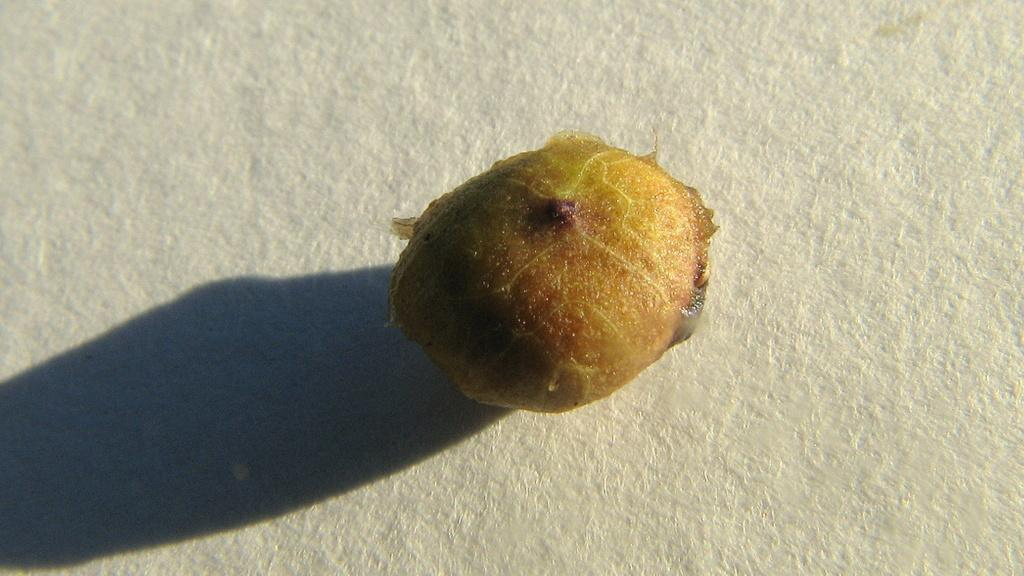What is the main subject of the image? There is an object in the image. What color is the background of the image? The background of the image is white. Can you tell me how many people are observing the lake in the image? There is no lake present in the image, and therefore no people can be observed observing it. 